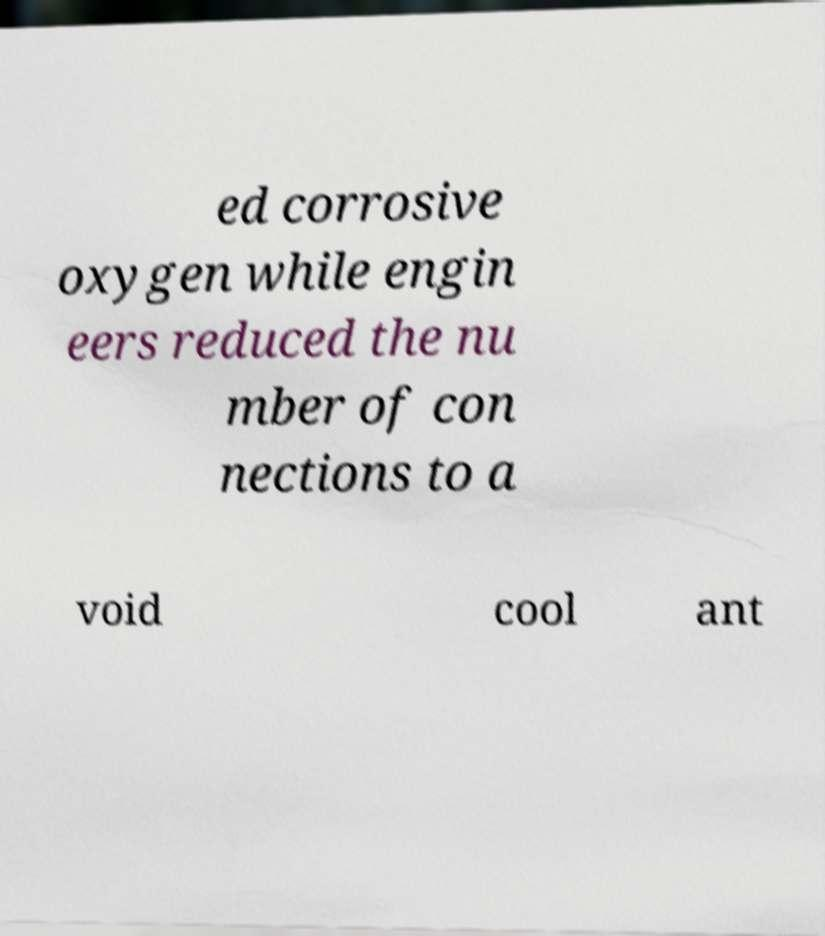Could you assist in decoding the text presented in this image and type it out clearly? ed corrosive oxygen while engin eers reduced the nu mber of con nections to a void cool ant 